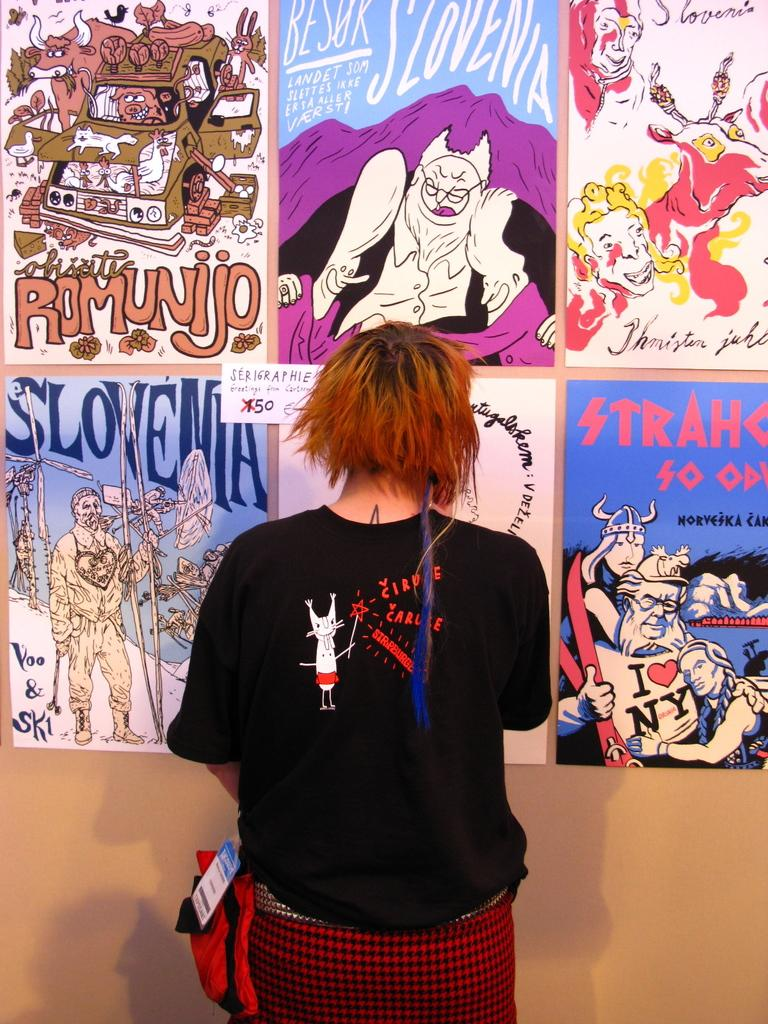<image>
Present a compact description of the photo's key features. woman in black shirt with red hair standing in front of posters for slovenia, romunijo and others 